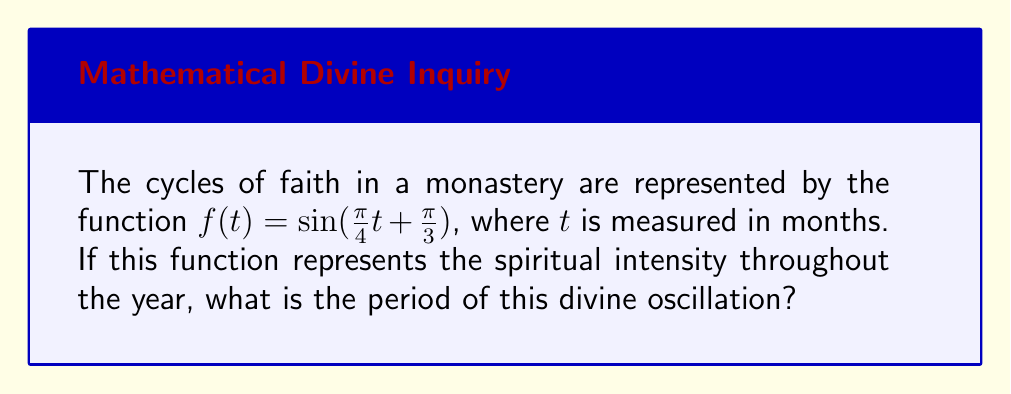Solve this math problem. Let us approach this problem step-by-step, as if we were uncovering the mysteries of divine wisdom:

1) The general form of a sine function is:
   $f(t) = A \sin(Bt + C) + D$

2) In our case, $A = 1$, $B = \frac{\pi}{4}$, $C = \frac{\pi}{3}$, and $D = 0$

3) The period of a trigonometric function is given by the formula:
   $\text{Period} = \frac{2\pi}{|B|}$

4) Substituting our value of $B$:
   $\text{Period} = \frac{2\pi}{|\frac{\pi}{4}|}$

5) Simplify:
   $\text{Period} = \frac{2\pi}{\frac{\pi}{4}} = 2 \cdot \frac{4}{1} = 8$

6) Since $t$ is measured in months, the period is 8 months.

Thus, like the cycle of liturgical seasons, the spiritual intensity in this monastery completes a full cycle every 8 months.
Answer: 8 months 